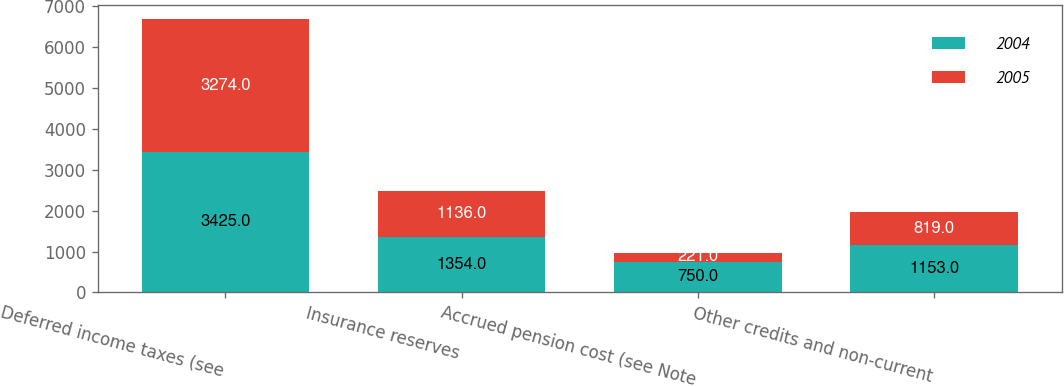Convert chart to OTSL. <chart><loc_0><loc_0><loc_500><loc_500><stacked_bar_chart><ecel><fcel>Deferred income taxes (see<fcel>Insurance reserves<fcel>Accrued pension cost (see Note<fcel>Other credits and non-current<nl><fcel>2004<fcel>3425<fcel>1354<fcel>750<fcel>1153<nl><fcel>2005<fcel>3274<fcel>1136<fcel>221<fcel>819<nl></chart> 